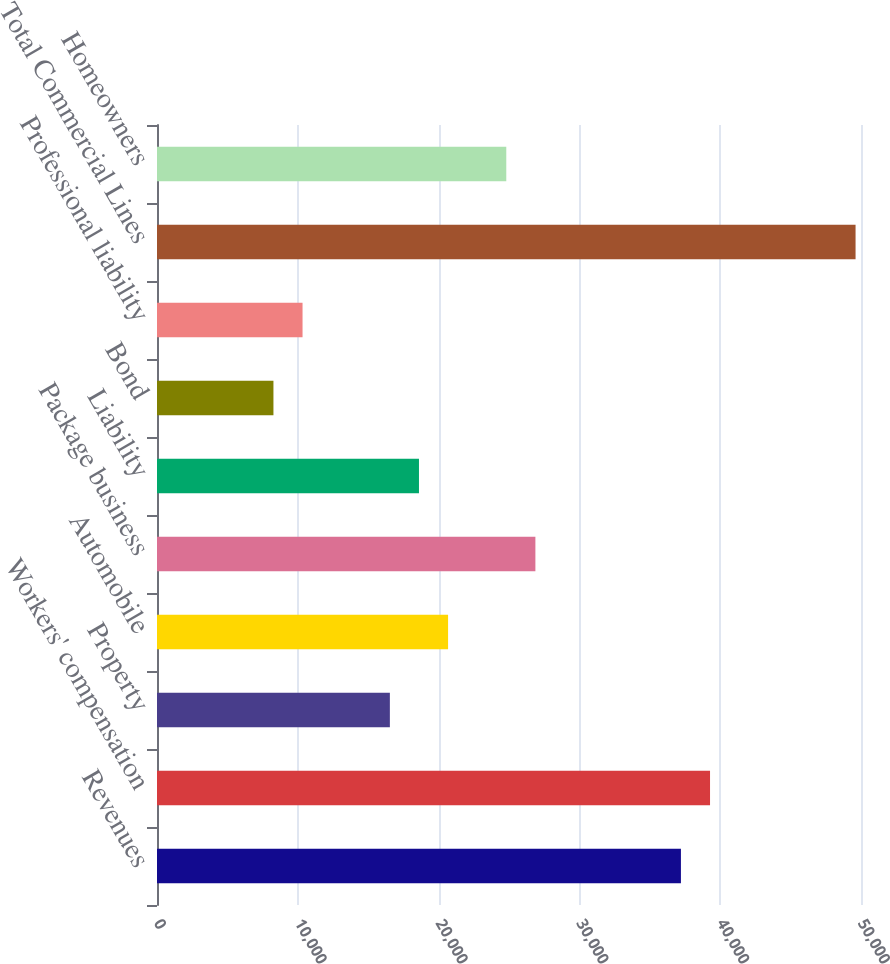Convert chart to OTSL. <chart><loc_0><loc_0><loc_500><loc_500><bar_chart><fcel>Revenues<fcel>Workers' compensation<fcel>Property<fcel>Automobile<fcel>Package business<fcel>Liability<fcel>Bond<fcel>Professional liability<fcel>Total Commercial Lines<fcel>Homeowners<nl><fcel>37210.6<fcel>39277.8<fcel>16538.6<fcel>20673<fcel>26874.6<fcel>18605.8<fcel>8269.8<fcel>10337<fcel>49613.8<fcel>24807.4<nl></chart> 